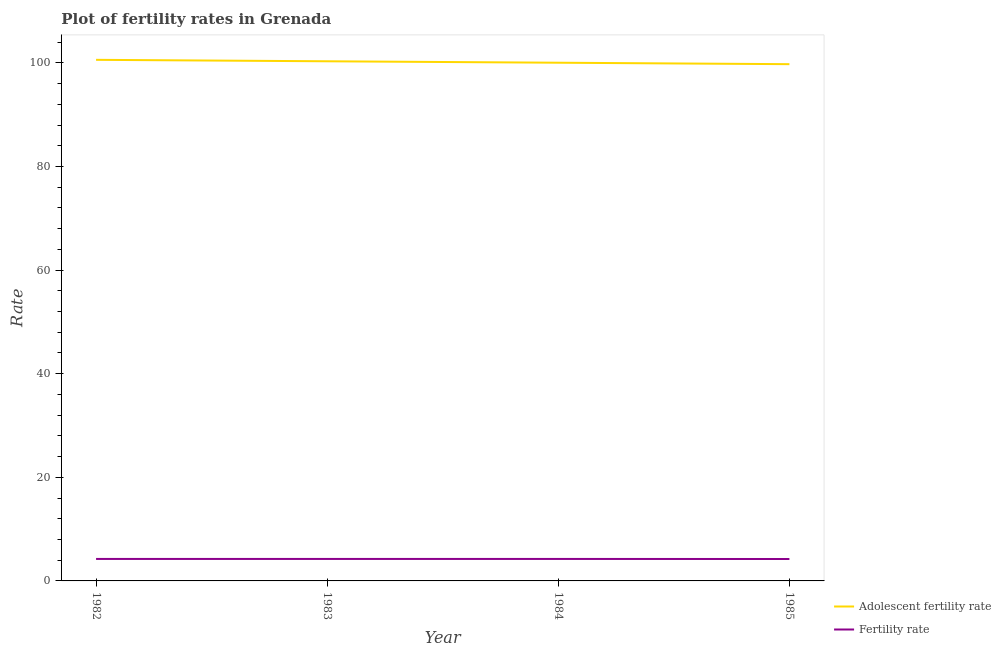Does the line corresponding to adolescent fertility rate intersect with the line corresponding to fertility rate?
Ensure brevity in your answer.  No. Is the number of lines equal to the number of legend labels?
Your answer should be very brief. Yes. What is the fertility rate in 1983?
Your answer should be very brief. 4.25. Across all years, what is the maximum adolescent fertility rate?
Your answer should be very brief. 100.59. Across all years, what is the minimum fertility rate?
Make the answer very short. 4.23. In which year was the adolescent fertility rate maximum?
Your response must be concise. 1982. In which year was the fertility rate minimum?
Your answer should be compact. 1985. What is the total adolescent fertility rate in the graph?
Make the answer very short. 400.68. What is the difference between the adolescent fertility rate in 1982 and that in 1985?
Offer a terse response. 0.84. What is the difference between the fertility rate in 1985 and the adolescent fertility rate in 1982?
Your answer should be compact. -96.36. What is the average fertility rate per year?
Keep it short and to the point. 4.24. In the year 1985, what is the difference between the adolescent fertility rate and fertility rate?
Offer a terse response. 95.52. What is the ratio of the adolescent fertility rate in 1982 to that in 1985?
Your answer should be very brief. 1.01. Is the adolescent fertility rate in 1984 less than that in 1985?
Give a very brief answer. No. What is the difference between the highest and the second highest adolescent fertility rate?
Your answer should be compact. 0.28. What is the difference between the highest and the lowest fertility rate?
Make the answer very short. 0.01. In how many years, is the adolescent fertility rate greater than the average adolescent fertility rate taken over all years?
Make the answer very short. 2. Is the adolescent fertility rate strictly greater than the fertility rate over the years?
Ensure brevity in your answer.  Yes. Is the fertility rate strictly less than the adolescent fertility rate over the years?
Make the answer very short. Yes. How many legend labels are there?
Offer a very short reply. 2. What is the title of the graph?
Your response must be concise. Plot of fertility rates in Grenada. Does "Commercial bank branches" appear as one of the legend labels in the graph?
Your response must be concise. No. What is the label or title of the X-axis?
Provide a succinct answer. Year. What is the label or title of the Y-axis?
Provide a succinct answer. Rate. What is the Rate in Adolescent fertility rate in 1982?
Offer a terse response. 100.59. What is the Rate of Fertility rate in 1982?
Ensure brevity in your answer.  4.24. What is the Rate in Adolescent fertility rate in 1983?
Your response must be concise. 100.31. What is the Rate of Fertility rate in 1983?
Ensure brevity in your answer.  4.25. What is the Rate of Adolescent fertility rate in 1984?
Your response must be concise. 100.03. What is the Rate in Fertility rate in 1984?
Your response must be concise. 4.24. What is the Rate in Adolescent fertility rate in 1985?
Provide a short and direct response. 99.75. What is the Rate of Fertility rate in 1985?
Your answer should be compact. 4.23. Across all years, what is the maximum Rate in Adolescent fertility rate?
Your answer should be very brief. 100.59. Across all years, what is the maximum Rate of Fertility rate?
Offer a very short reply. 4.25. Across all years, what is the minimum Rate of Adolescent fertility rate?
Make the answer very short. 99.75. Across all years, what is the minimum Rate of Fertility rate?
Ensure brevity in your answer.  4.23. What is the total Rate of Adolescent fertility rate in the graph?
Offer a very short reply. 400.68. What is the total Rate in Fertility rate in the graph?
Make the answer very short. 16.96. What is the difference between the Rate in Adolescent fertility rate in 1982 and that in 1983?
Provide a succinct answer. 0.28. What is the difference between the Rate in Fertility rate in 1982 and that in 1983?
Offer a terse response. -0. What is the difference between the Rate of Adolescent fertility rate in 1982 and that in 1984?
Offer a very short reply. 0.56. What is the difference between the Rate of Fertility rate in 1982 and that in 1984?
Give a very brief answer. 0. What is the difference between the Rate of Adolescent fertility rate in 1982 and that in 1985?
Give a very brief answer. 0.84. What is the difference between the Rate in Fertility rate in 1982 and that in 1985?
Offer a terse response. 0.01. What is the difference between the Rate of Adolescent fertility rate in 1983 and that in 1984?
Give a very brief answer. 0.28. What is the difference between the Rate in Fertility rate in 1983 and that in 1984?
Offer a terse response. 0. What is the difference between the Rate in Adolescent fertility rate in 1983 and that in 1985?
Ensure brevity in your answer.  0.56. What is the difference between the Rate in Fertility rate in 1983 and that in 1985?
Your response must be concise. 0.01. What is the difference between the Rate of Adolescent fertility rate in 1984 and that in 1985?
Give a very brief answer. 0.28. What is the difference between the Rate of Fertility rate in 1984 and that in 1985?
Your response must be concise. 0.01. What is the difference between the Rate in Adolescent fertility rate in 1982 and the Rate in Fertility rate in 1983?
Your response must be concise. 96.34. What is the difference between the Rate of Adolescent fertility rate in 1982 and the Rate of Fertility rate in 1984?
Your answer should be very brief. 96.35. What is the difference between the Rate of Adolescent fertility rate in 1982 and the Rate of Fertility rate in 1985?
Offer a very short reply. 96.36. What is the difference between the Rate of Adolescent fertility rate in 1983 and the Rate of Fertility rate in 1984?
Offer a very short reply. 96.07. What is the difference between the Rate in Adolescent fertility rate in 1983 and the Rate in Fertility rate in 1985?
Offer a very short reply. 96.08. What is the difference between the Rate in Adolescent fertility rate in 1984 and the Rate in Fertility rate in 1985?
Give a very brief answer. 95.8. What is the average Rate of Adolescent fertility rate per year?
Make the answer very short. 100.17. What is the average Rate of Fertility rate per year?
Offer a very short reply. 4.24. In the year 1982, what is the difference between the Rate in Adolescent fertility rate and Rate in Fertility rate?
Provide a short and direct response. 96.35. In the year 1983, what is the difference between the Rate of Adolescent fertility rate and Rate of Fertility rate?
Give a very brief answer. 96.06. In the year 1984, what is the difference between the Rate of Adolescent fertility rate and Rate of Fertility rate?
Your answer should be very brief. 95.79. In the year 1985, what is the difference between the Rate in Adolescent fertility rate and Rate in Fertility rate?
Give a very brief answer. 95.52. What is the ratio of the Rate in Fertility rate in 1982 to that in 1983?
Ensure brevity in your answer.  1. What is the ratio of the Rate of Adolescent fertility rate in 1982 to that in 1984?
Provide a short and direct response. 1.01. What is the ratio of the Rate in Adolescent fertility rate in 1982 to that in 1985?
Offer a very short reply. 1.01. What is the ratio of the Rate of Fertility rate in 1982 to that in 1985?
Offer a terse response. 1. What is the ratio of the Rate in Fertility rate in 1983 to that in 1984?
Provide a short and direct response. 1. What is the ratio of the Rate of Adolescent fertility rate in 1983 to that in 1985?
Ensure brevity in your answer.  1.01. What is the ratio of the Rate of Adolescent fertility rate in 1984 to that in 1985?
Keep it short and to the point. 1. What is the ratio of the Rate in Fertility rate in 1984 to that in 1985?
Ensure brevity in your answer.  1. What is the difference between the highest and the second highest Rate in Adolescent fertility rate?
Give a very brief answer. 0.28. What is the difference between the highest and the second highest Rate of Fertility rate?
Your response must be concise. 0. What is the difference between the highest and the lowest Rate of Adolescent fertility rate?
Offer a very short reply. 0.84. What is the difference between the highest and the lowest Rate of Fertility rate?
Provide a succinct answer. 0.01. 